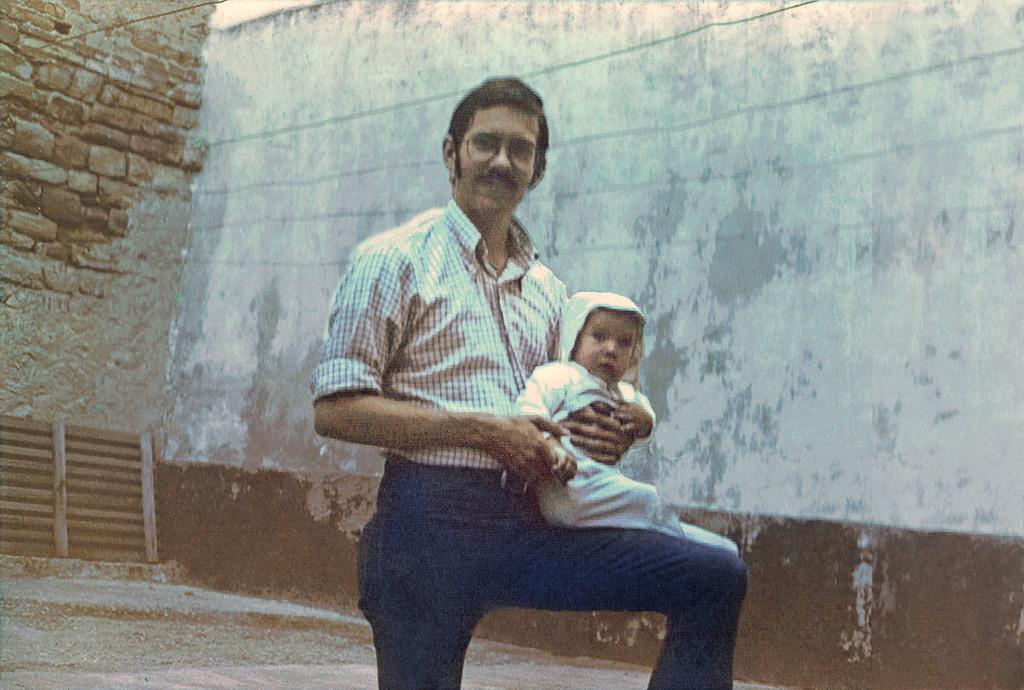What is happening in the image involving the person? There is a person in the image who is smiling and holding a baby. Can you describe the baby's position in relation to the person? The baby is on the person's lap. What can be seen on the white wall in the background of the image? There are lines on the white wall in the background of the image. What other type of wall is visible in the background? There is a brick wall in the background of the image. What type of pleasure is the person experiencing while holding the loaf of bread in the image? There is no loaf of bread present in the image, and the person is holding a baby, not a loaf of bread. What role does the minister play in the image? There is no minister present in the image. 